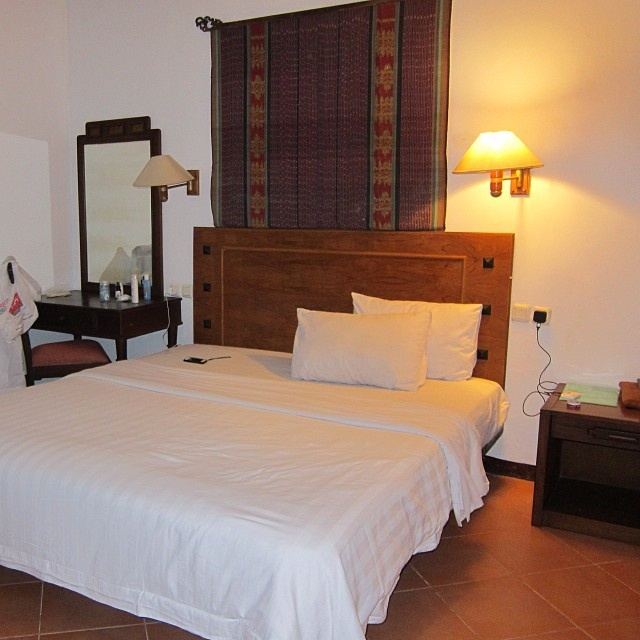Describe the objects in this image and their specific colors. I can see bed in darkgray, maroon, and tan tones, chair in darkgray, black, maroon, and gray tones, cell phone in darkgray, black, and gray tones, and cell phone in darkgray, tan, gray, and lightpink tones in this image. 